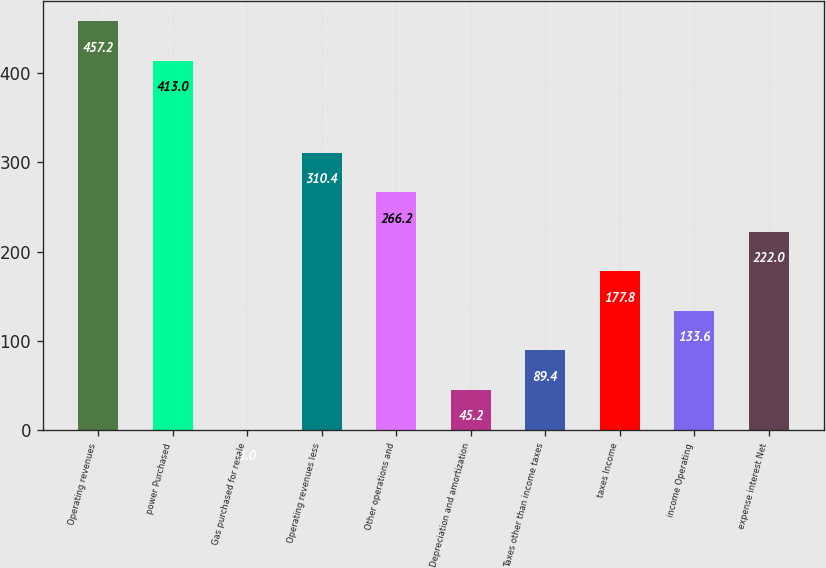<chart> <loc_0><loc_0><loc_500><loc_500><bar_chart><fcel>Operating revenues<fcel>power Purchased<fcel>Gas purchased for resale<fcel>Operating revenues less<fcel>Other operations and<fcel>Depreciation and amortization<fcel>Taxes other than income taxes<fcel>taxes Income<fcel>income Operating<fcel>expense interest Net<nl><fcel>457.2<fcel>413<fcel>1<fcel>310.4<fcel>266.2<fcel>45.2<fcel>89.4<fcel>177.8<fcel>133.6<fcel>222<nl></chart> 